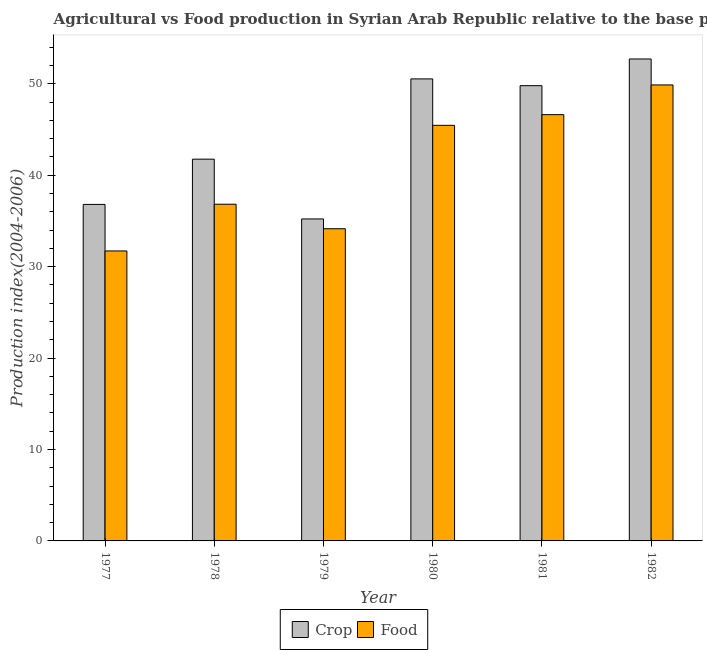How many different coloured bars are there?
Your response must be concise. 2. How many groups of bars are there?
Provide a short and direct response. 6. How many bars are there on the 6th tick from the right?
Provide a short and direct response. 2. What is the crop production index in 1981?
Make the answer very short. 49.8. Across all years, what is the maximum food production index?
Keep it short and to the point. 49.88. Across all years, what is the minimum crop production index?
Your answer should be very brief. 35.22. In which year was the crop production index maximum?
Give a very brief answer. 1982. In which year was the food production index minimum?
Your answer should be very brief. 1977. What is the total food production index in the graph?
Offer a very short reply. 244.67. What is the difference between the crop production index in 1978 and that in 1981?
Keep it short and to the point. -8.04. What is the difference between the food production index in 1978 and the crop production index in 1980?
Provide a succinct answer. -8.63. What is the average crop production index per year?
Offer a very short reply. 44.48. What is the ratio of the crop production index in 1978 to that in 1979?
Offer a terse response. 1.19. Is the food production index in 1977 less than that in 1979?
Ensure brevity in your answer.  Yes. What is the difference between the highest and the second highest crop production index?
Provide a short and direct response. 2.18. What is the difference between the highest and the lowest food production index?
Make the answer very short. 18.16. Is the sum of the crop production index in 1979 and 1981 greater than the maximum food production index across all years?
Your answer should be compact. Yes. What does the 2nd bar from the left in 1979 represents?
Make the answer very short. Food. What does the 1st bar from the right in 1978 represents?
Ensure brevity in your answer.  Food. How many bars are there?
Give a very brief answer. 12. Does the graph contain any zero values?
Your answer should be compact. No. Does the graph contain grids?
Ensure brevity in your answer.  No. Where does the legend appear in the graph?
Make the answer very short. Bottom center. How many legend labels are there?
Keep it short and to the point. 2. What is the title of the graph?
Your answer should be very brief. Agricultural vs Food production in Syrian Arab Republic relative to the base period 2004-2006. What is the label or title of the X-axis?
Offer a very short reply. Year. What is the label or title of the Y-axis?
Ensure brevity in your answer.  Production index(2004-2006). What is the Production index(2004-2006) of Crop in 1977?
Your answer should be compact. 36.81. What is the Production index(2004-2006) in Food in 1977?
Your answer should be very brief. 31.72. What is the Production index(2004-2006) in Crop in 1978?
Keep it short and to the point. 41.76. What is the Production index(2004-2006) in Food in 1978?
Keep it short and to the point. 36.83. What is the Production index(2004-2006) of Crop in 1979?
Offer a very short reply. 35.22. What is the Production index(2004-2006) of Food in 1979?
Offer a terse response. 34.15. What is the Production index(2004-2006) of Crop in 1980?
Ensure brevity in your answer.  50.54. What is the Production index(2004-2006) of Food in 1980?
Keep it short and to the point. 45.46. What is the Production index(2004-2006) of Crop in 1981?
Your answer should be compact. 49.8. What is the Production index(2004-2006) in Food in 1981?
Your answer should be very brief. 46.63. What is the Production index(2004-2006) of Crop in 1982?
Offer a very short reply. 52.72. What is the Production index(2004-2006) in Food in 1982?
Ensure brevity in your answer.  49.88. Across all years, what is the maximum Production index(2004-2006) of Crop?
Your response must be concise. 52.72. Across all years, what is the maximum Production index(2004-2006) of Food?
Provide a succinct answer. 49.88. Across all years, what is the minimum Production index(2004-2006) in Crop?
Offer a very short reply. 35.22. Across all years, what is the minimum Production index(2004-2006) in Food?
Offer a very short reply. 31.72. What is the total Production index(2004-2006) in Crop in the graph?
Give a very brief answer. 266.85. What is the total Production index(2004-2006) in Food in the graph?
Ensure brevity in your answer.  244.67. What is the difference between the Production index(2004-2006) of Crop in 1977 and that in 1978?
Give a very brief answer. -4.95. What is the difference between the Production index(2004-2006) of Food in 1977 and that in 1978?
Your answer should be compact. -5.11. What is the difference between the Production index(2004-2006) in Crop in 1977 and that in 1979?
Make the answer very short. 1.59. What is the difference between the Production index(2004-2006) of Food in 1977 and that in 1979?
Make the answer very short. -2.43. What is the difference between the Production index(2004-2006) in Crop in 1977 and that in 1980?
Your response must be concise. -13.73. What is the difference between the Production index(2004-2006) of Food in 1977 and that in 1980?
Your response must be concise. -13.74. What is the difference between the Production index(2004-2006) in Crop in 1977 and that in 1981?
Offer a very short reply. -12.99. What is the difference between the Production index(2004-2006) in Food in 1977 and that in 1981?
Ensure brevity in your answer.  -14.91. What is the difference between the Production index(2004-2006) in Crop in 1977 and that in 1982?
Your answer should be compact. -15.91. What is the difference between the Production index(2004-2006) of Food in 1977 and that in 1982?
Ensure brevity in your answer.  -18.16. What is the difference between the Production index(2004-2006) in Crop in 1978 and that in 1979?
Make the answer very short. 6.54. What is the difference between the Production index(2004-2006) in Food in 1978 and that in 1979?
Provide a succinct answer. 2.68. What is the difference between the Production index(2004-2006) in Crop in 1978 and that in 1980?
Your answer should be compact. -8.78. What is the difference between the Production index(2004-2006) in Food in 1978 and that in 1980?
Offer a very short reply. -8.63. What is the difference between the Production index(2004-2006) of Crop in 1978 and that in 1981?
Your response must be concise. -8.04. What is the difference between the Production index(2004-2006) in Crop in 1978 and that in 1982?
Ensure brevity in your answer.  -10.96. What is the difference between the Production index(2004-2006) in Food in 1978 and that in 1982?
Offer a terse response. -13.05. What is the difference between the Production index(2004-2006) in Crop in 1979 and that in 1980?
Your answer should be very brief. -15.32. What is the difference between the Production index(2004-2006) of Food in 1979 and that in 1980?
Keep it short and to the point. -11.31. What is the difference between the Production index(2004-2006) in Crop in 1979 and that in 1981?
Provide a succinct answer. -14.58. What is the difference between the Production index(2004-2006) of Food in 1979 and that in 1981?
Provide a succinct answer. -12.48. What is the difference between the Production index(2004-2006) of Crop in 1979 and that in 1982?
Give a very brief answer. -17.5. What is the difference between the Production index(2004-2006) of Food in 1979 and that in 1982?
Offer a very short reply. -15.73. What is the difference between the Production index(2004-2006) in Crop in 1980 and that in 1981?
Your answer should be very brief. 0.74. What is the difference between the Production index(2004-2006) of Food in 1980 and that in 1981?
Give a very brief answer. -1.17. What is the difference between the Production index(2004-2006) in Crop in 1980 and that in 1982?
Your answer should be compact. -2.18. What is the difference between the Production index(2004-2006) in Food in 1980 and that in 1982?
Ensure brevity in your answer.  -4.42. What is the difference between the Production index(2004-2006) of Crop in 1981 and that in 1982?
Keep it short and to the point. -2.92. What is the difference between the Production index(2004-2006) of Food in 1981 and that in 1982?
Keep it short and to the point. -3.25. What is the difference between the Production index(2004-2006) of Crop in 1977 and the Production index(2004-2006) of Food in 1978?
Provide a succinct answer. -0.02. What is the difference between the Production index(2004-2006) in Crop in 1977 and the Production index(2004-2006) in Food in 1979?
Your response must be concise. 2.66. What is the difference between the Production index(2004-2006) in Crop in 1977 and the Production index(2004-2006) in Food in 1980?
Keep it short and to the point. -8.65. What is the difference between the Production index(2004-2006) in Crop in 1977 and the Production index(2004-2006) in Food in 1981?
Offer a terse response. -9.82. What is the difference between the Production index(2004-2006) in Crop in 1977 and the Production index(2004-2006) in Food in 1982?
Offer a very short reply. -13.07. What is the difference between the Production index(2004-2006) in Crop in 1978 and the Production index(2004-2006) in Food in 1979?
Provide a succinct answer. 7.61. What is the difference between the Production index(2004-2006) in Crop in 1978 and the Production index(2004-2006) in Food in 1981?
Keep it short and to the point. -4.87. What is the difference between the Production index(2004-2006) of Crop in 1978 and the Production index(2004-2006) of Food in 1982?
Your response must be concise. -8.12. What is the difference between the Production index(2004-2006) in Crop in 1979 and the Production index(2004-2006) in Food in 1980?
Provide a succinct answer. -10.24. What is the difference between the Production index(2004-2006) in Crop in 1979 and the Production index(2004-2006) in Food in 1981?
Make the answer very short. -11.41. What is the difference between the Production index(2004-2006) of Crop in 1979 and the Production index(2004-2006) of Food in 1982?
Your response must be concise. -14.66. What is the difference between the Production index(2004-2006) of Crop in 1980 and the Production index(2004-2006) of Food in 1981?
Keep it short and to the point. 3.91. What is the difference between the Production index(2004-2006) in Crop in 1980 and the Production index(2004-2006) in Food in 1982?
Ensure brevity in your answer.  0.66. What is the difference between the Production index(2004-2006) of Crop in 1981 and the Production index(2004-2006) of Food in 1982?
Make the answer very short. -0.08. What is the average Production index(2004-2006) of Crop per year?
Offer a very short reply. 44.48. What is the average Production index(2004-2006) in Food per year?
Your answer should be very brief. 40.78. In the year 1977, what is the difference between the Production index(2004-2006) of Crop and Production index(2004-2006) of Food?
Offer a terse response. 5.09. In the year 1978, what is the difference between the Production index(2004-2006) of Crop and Production index(2004-2006) of Food?
Provide a short and direct response. 4.93. In the year 1979, what is the difference between the Production index(2004-2006) of Crop and Production index(2004-2006) of Food?
Keep it short and to the point. 1.07. In the year 1980, what is the difference between the Production index(2004-2006) in Crop and Production index(2004-2006) in Food?
Your response must be concise. 5.08. In the year 1981, what is the difference between the Production index(2004-2006) in Crop and Production index(2004-2006) in Food?
Keep it short and to the point. 3.17. In the year 1982, what is the difference between the Production index(2004-2006) of Crop and Production index(2004-2006) of Food?
Offer a terse response. 2.84. What is the ratio of the Production index(2004-2006) in Crop in 1977 to that in 1978?
Offer a terse response. 0.88. What is the ratio of the Production index(2004-2006) in Food in 1977 to that in 1978?
Offer a terse response. 0.86. What is the ratio of the Production index(2004-2006) in Crop in 1977 to that in 1979?
Provide a short and direct response. 1.05. What is the ratio of the Production index(2004-2006) of Food in 1977 to that in 1979?
Keep it short and to the point. 0.93. What is the ratio of the Production index(2004-2006) in Crop in 1977 to that in 1980?
Make the answer very short. 0.73. What is the ratio of the Production index(2004-2006) in Food in 1977 to that in 1980?
Your response must be concise. 0.7. What is the ratio of the Production index(2004-2006) in Crop in 1977 to that in 1981?
Your response must be concise. 0.74. What is the ratio of the Production index(2004-2006) of Food in 1977 to that in 1981?
Give a very brief answer. 0.68. What is the ratio of the Production index(2004-2006) of Crop in 1977 to that in 1982?
Provide a short and direct response. 0.7. What is the ratio of the Production index(2004-2006) in Food in 1977 to that in 1982?
Offer a very short reply. 0.64. What is the ratio of the Production index(2004-2006) of Crop in 1978 to that in 1979?
Your answer should be very brief. 1.19. What is the ratio of the Production index(2004-2006) of Food in 1978 to that in 1979?
Provide a short and direct response. 1.08. What is the ratio of the Production index(2004-2006) of Crop in 1978 to that in 1980?
Offer a terse response. 0.83. What is the ratio of the Production index(2004-2006) of Food in 1978 to that in 1980?
Keep it short and to the point. 0.81. What is the ratio of the Production index(2004-2006) in Crop in 1978 to that in 1981?
Your response must be concise. 0.84. What is the ratio of the Production index(2004-2006) in Food in 1978 to that in 1981?
Your answer should be compact. 0.79. What is the ratio of the Production index(2004-2006) in Crop in 1978 to that in 1982?
Your response must be concise. 0.79. What is the ratio of the Production index(2004-2006) in Food in 1978 to that in 1982?
Offer a terse response. 0.74. What is the ratio of the Production index(2004-2006) in Crop in 1979 to that in 1980?
Give a very brief answer. 0.7. What is the ratio of the Production index(2004-2006) in Food in 1979 to that in 1980?
Ensure brevity in your answer.  0.75. What is the ratio of the Production index(2004-2006) in Crop in 1979 to that in 1981?
Your answer should be compact. 0.71. What is the ratio of the Production index(2004-2006) in Food in 1979 to that in 1981?
Offer a terse response. 0.73. What is the ratio of the Production index(2004-2006) of Crop in 1979 to that in 1982?
Offer a terse response. 0.67. What is the ratio of the Production index(2004-2006) in Food in 1979 to that in 1982?
Your answer should be very brief. 0.68. What is the ratio of the Production index(2004-2006) in Crop in 1980 to that in 1981?
Your response must be concise. 1.01. What is the ratio of the Production index(2004-2006) in Food in 1980 to that in 1981?
Offer a terse response. 0.97. What is the ratio of the Production index(2004-2006) in Crop in 1980 to that in 1982?
Provide a succinct answer. 0.96. What is the ratio of the Production index(2004-2006) of Food in 1980 to that in 1982?
Offer a very short reply. 0.91. What is the ratio of the Production index(2004-2006) in Crop in 1981 to that in 1982?
Ensure brevity in your answer.  0.94. What is the ratio of the Production index(2004-2006) in Food in 1981 to that in 1982?
Your answer should be very brief. 0.93. What is the difference between the highest and the second highest Production index(2004-2006) in Crop?
Keep it short and to the point. 2.18. What is the difference between the highest and the lowest Production index(2004-2006) of Food?
Offer a very short reply. 18.16. 